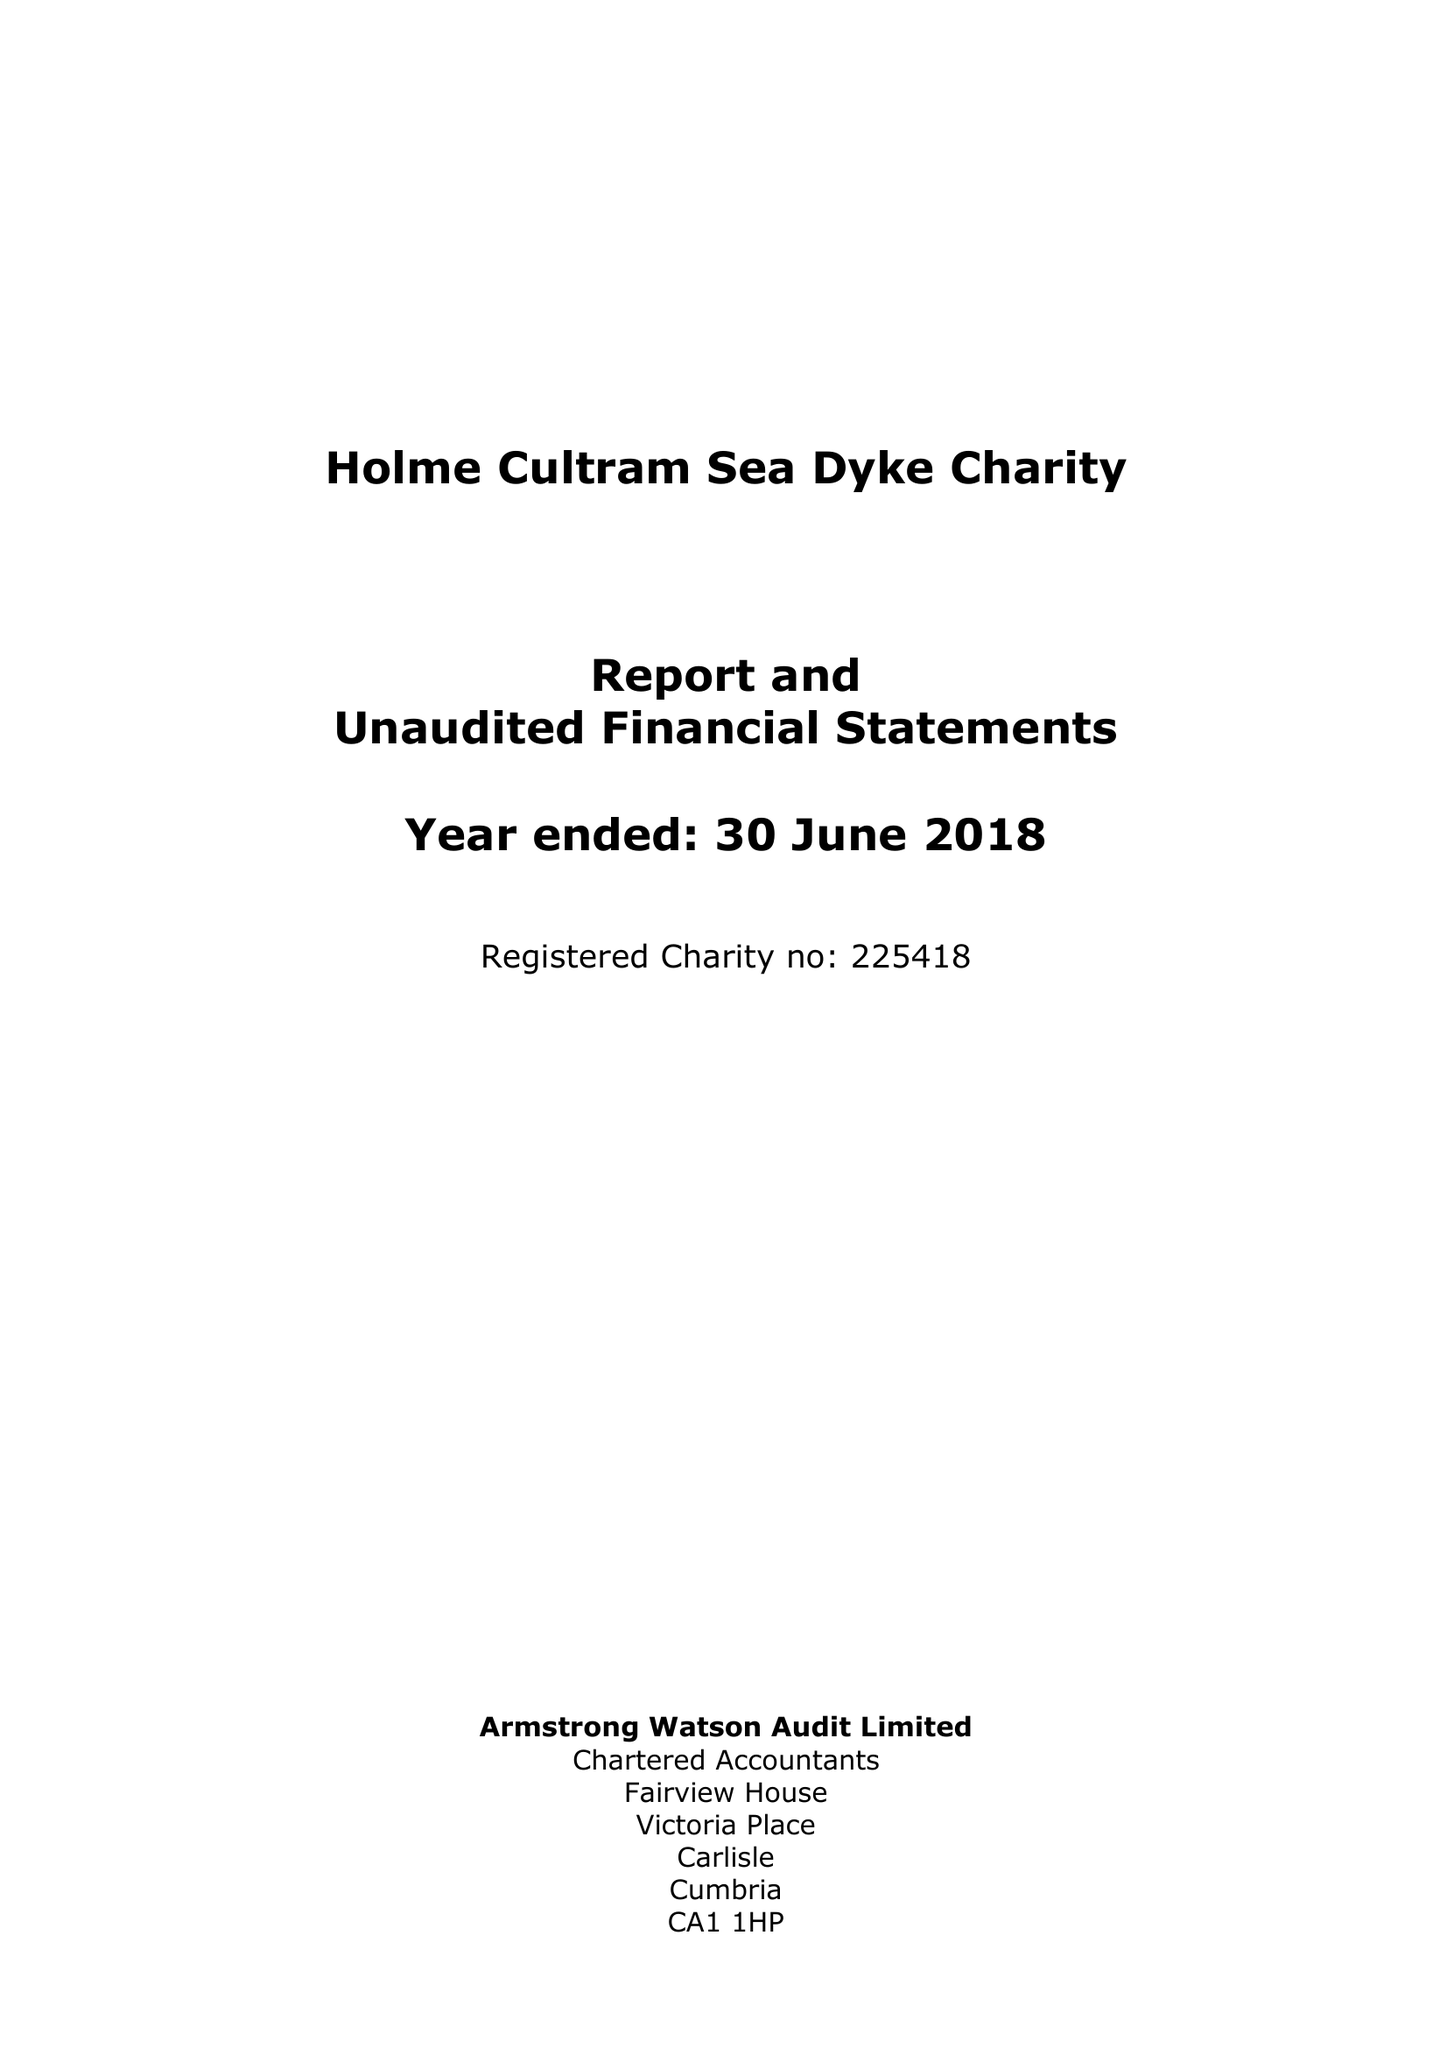What is the value for the income_annually_in_british_pounds?
Answer the question using a single word or phrase. 33950.00 